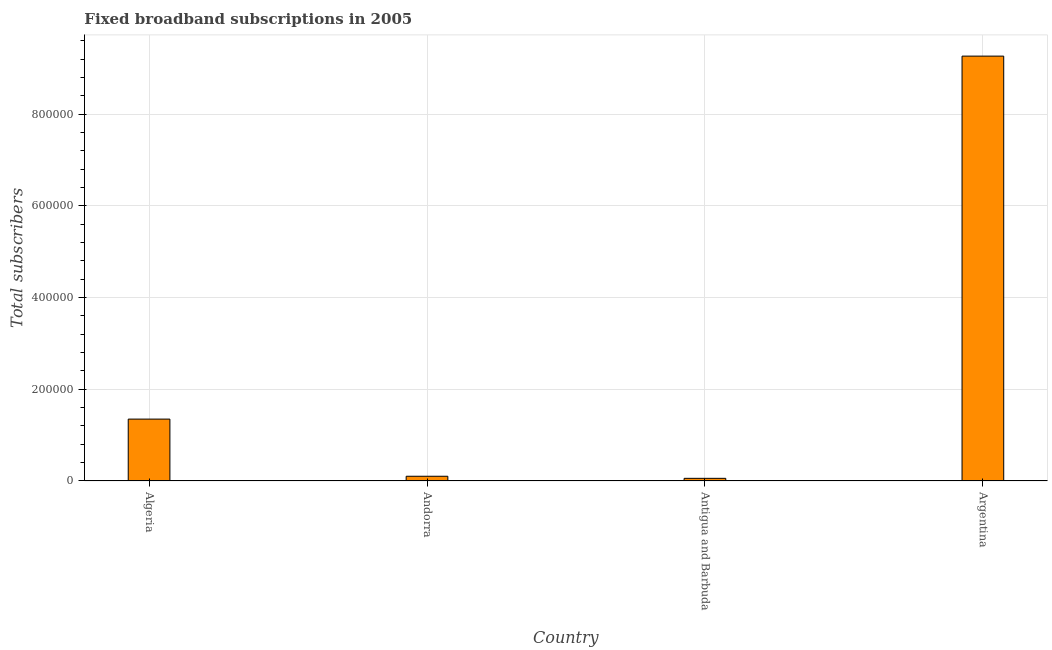Does the graph contain grids?
Make the answer very short. Yes. What is the title of the graph?
Keep it short and to the point. Fixed broadband subscriptions in 2005. What is the label or title of the Y-axis?
Your answer should be very brief. Total subscribers. What is the total number of fixed broadband subscriptions in Andorra?
Make the answer very short. 1.03e+04. Across all countries, what is the maximum total number of fixed broadband subscriptions?
Provide a succinct answer. 9.27e+05. Across all countries, what is the minimum total number of fixed broadband subscriptions?
Your answer should be very brief. 5801. In which country was the total number of fixed broadband subscriptions maximum?
Provide a succinct answer. Argentina. In which country was the total number of fixed broadband subscriptions minimum?
Your response must be concise. Antigua and Barbuda. What is the sum of the total number of fixed broadband subscriptions?
Your response must be concise. 1.08e+06. What is the difference between the total number of fixed broadband subscriptions in Andorra and Antigua and Barbuda?
Provide a short and direct response. 4540. What is the average total number of fixed broadband subscriptions per country?
Provide a succinct answer. 2.69e+05. What is the median total number of fixed broadband subscriptions?
Give a very brief answer. 7.27e+04. What is the ratio of the total number of fixed broadband subscriptions in Algeria to that in Andorra?
Your answer should be compact. 13.05. Is the total number of fixed broadband subscriptions in Algeria less than that in Antigua and Barbuda?
Provide a short and direct response. No. Is the difference between the total number of fixed broadband subscriptions in Andorra and Antigua and Barbuda greater than the difference between any two countries?
Offer a very short reply. No. What is the difference between the highest and the second highest total number of fixed broadband subscriptions?
Offer a very short reply. 7.92e+05. Is the sum of the total number of fixed broadband subscriptions in Algeria and Andorra greater than the maximum total number of fixed broadband subscriptions across all countries?
Keep it short and to the point. No. What is the difference between the highest and the lowest total number of fixed broadband subscriptions?
Keep it short and to the point. 9.21e+05. In how many countries, is the total number of fixed broadband subscriptions greater than the average total number of fixed broadband subscriptions taken over all countries?
Keep it short and to the point. 1. How many countries are there in the graph?
Offer a terse response. 4. What is the difference between two consecutive major ticks on the Y-axis?
Your response must be concise. 2.00e+05. What is the Total subscribers of Algeria?
Provide a short and direct response. 1.35e+05. What is the Total subscribers in Andorra?
Your answer should be very brief. 1.03e+04. What is the Total subscribers of Antigua and Barbuda?
Keep it short and to the point. 5801. What is the Total subscribers in Argentina?
Keep it short and to the point. 9.27e+05. What is the difference between the Total subscribers in Algeria and Andorra?
Keep it short and to the point. 1.25e+05. What is the difference between the Total subscribers in Algeria and Antigua and Barbuda?
Ensure brevity in your answer.  1.29e+05. What is the difference between the Total subscribers in Algeria and Argentina?
Keep it short and to the point. -7.92e+05. What is the difference between the Total subscribers in Andorra and Antigua and Barbuda?
Your answer should be very brief. 4540. What is the difference between the Total subscribers in Andorra and Argentina?
Offer a very short reply. -9.16e+05. What is the difference between the Total subscribers in Antigua and Barbuda and Argentina?
Keep it short and to the point. -9.21e+05. What is the ratio of the Total subscribers in Algeria to that in Andorra?
Provide a succinct answer. 13.05. What is the ratio of the Total subscribers in Algeria to that in Antigua and Barbuda?
Give a very brief answer. 23.27. What is the ratio of the Total subscribers in Algeria to that in Argentina?
Provide a short and direct response. 0.15. What is the ratio of the Total subscribers in Andorra to that in Antigua and Barbuda?
Your answer should be compact. 1.78. What is the ratio of the Total subscribers in Andorra to that in Argentina?
Offer a terse response. 0.01. What is the ratio of the Total subscribers in Antigua and Barbuda to that in Argentina?
Give a very brief answer. 0.01. 